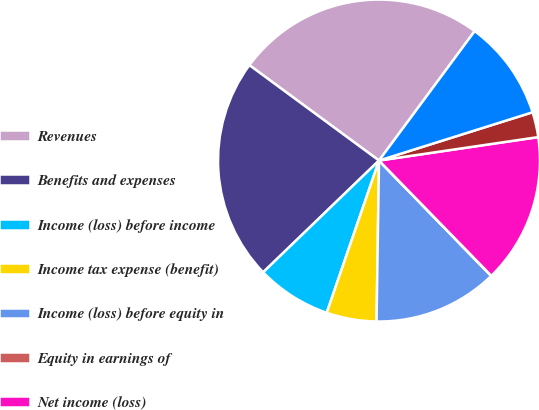Convert chart. <chart><loc_0><loc_0><loc_500><loc_500><pie_chart><fcel>Revenues<fcel>Benefits and expenses<fcel>Income (loss) before income<fcel>Income tax expense (benefit)<fcel>Income (loss) before equity in<fcel>Equity in earnings of<fcel>Net income (loss)<fcel>Less Income attributable to<fcel>Net income (loss) attributable<nl><fcel>25.03%<fcel>22.31%<fcel>7.52%<fcel>5.02%<fcel>12.52%<fcel>0.02%<fcel>15.03%<fcel>2.52%<fcel>10.02%<nl></chart> 